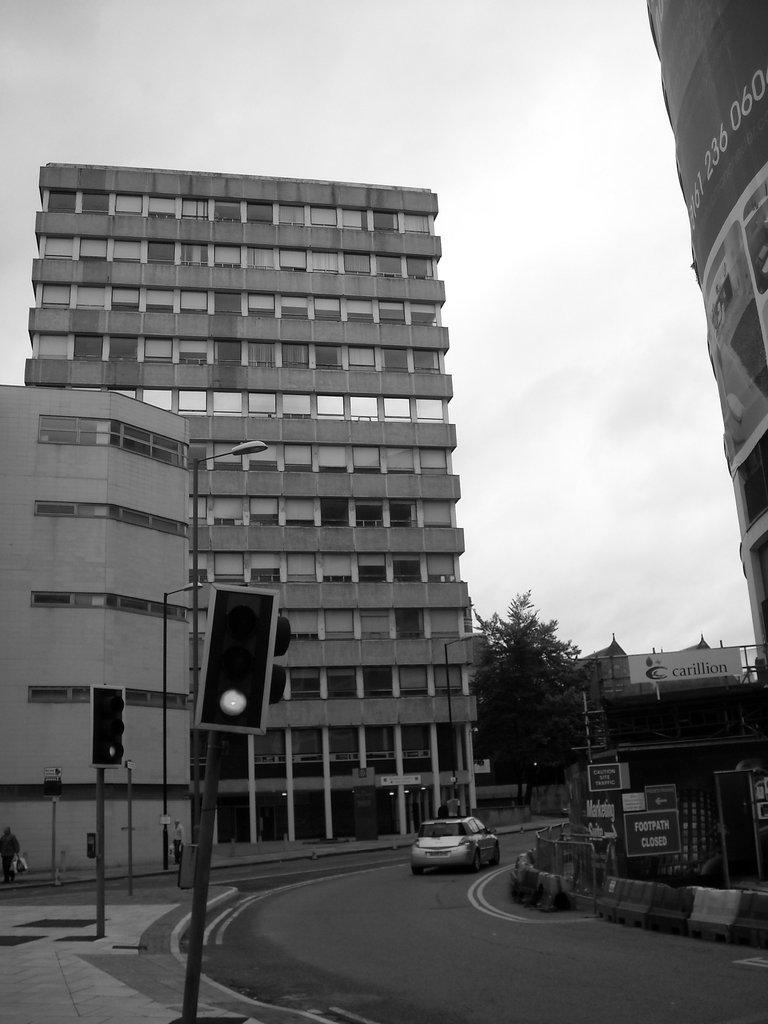What structure is located on the right side of the image? There is a building on the right side of the image. What can be seen on the left side of the image? There is a traffic signal and a light pole on the left side of the image. What other structures are present on the left side of the image? There are also buildings on the left side of the image. What can be seen in the background of the image? There are trees and the sky visible in the background of the image. How many hands are visible in the image? There are no hands visible in the image. Can you tell me how the traffic signal is used to control the flow of swimmers in the image? There are no swimmers present in the image, and the traffic signal is used to control the flow of vehicles, not swimmers. 